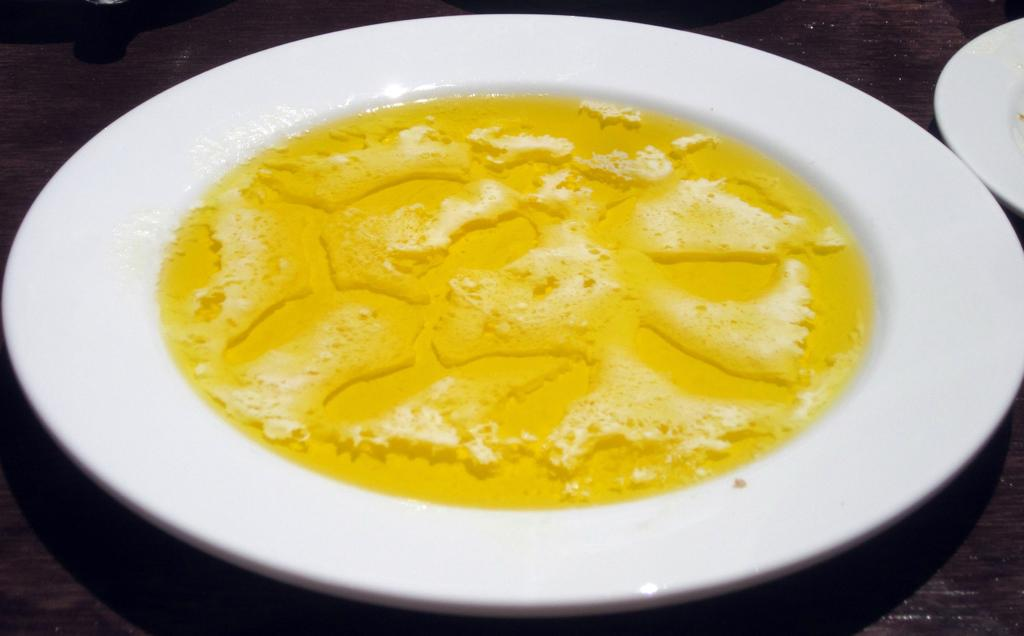What is the main object in the image? There is a table in the image. What is depicted on the table? There are planets depicted in the image. What else can be seen on the table? There is food placed on the table. What is the price of the bushes in the image? There are no bushes present in the image. How does the death of the planets affect the food on the table? There is no indication of the death of the planets or any effect on the food in the image. 